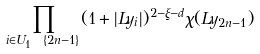<formula> <loc_0><loc_0><loc_500><loc_500>\prod _ { i \in U _ { 1 } \ \{ 2 n - 1 \} } ( 1 + | L y _ { i } | ) ^ { 2 - \xi - d } \chi ( L y _ { 2 n - 1 } )</formula> 